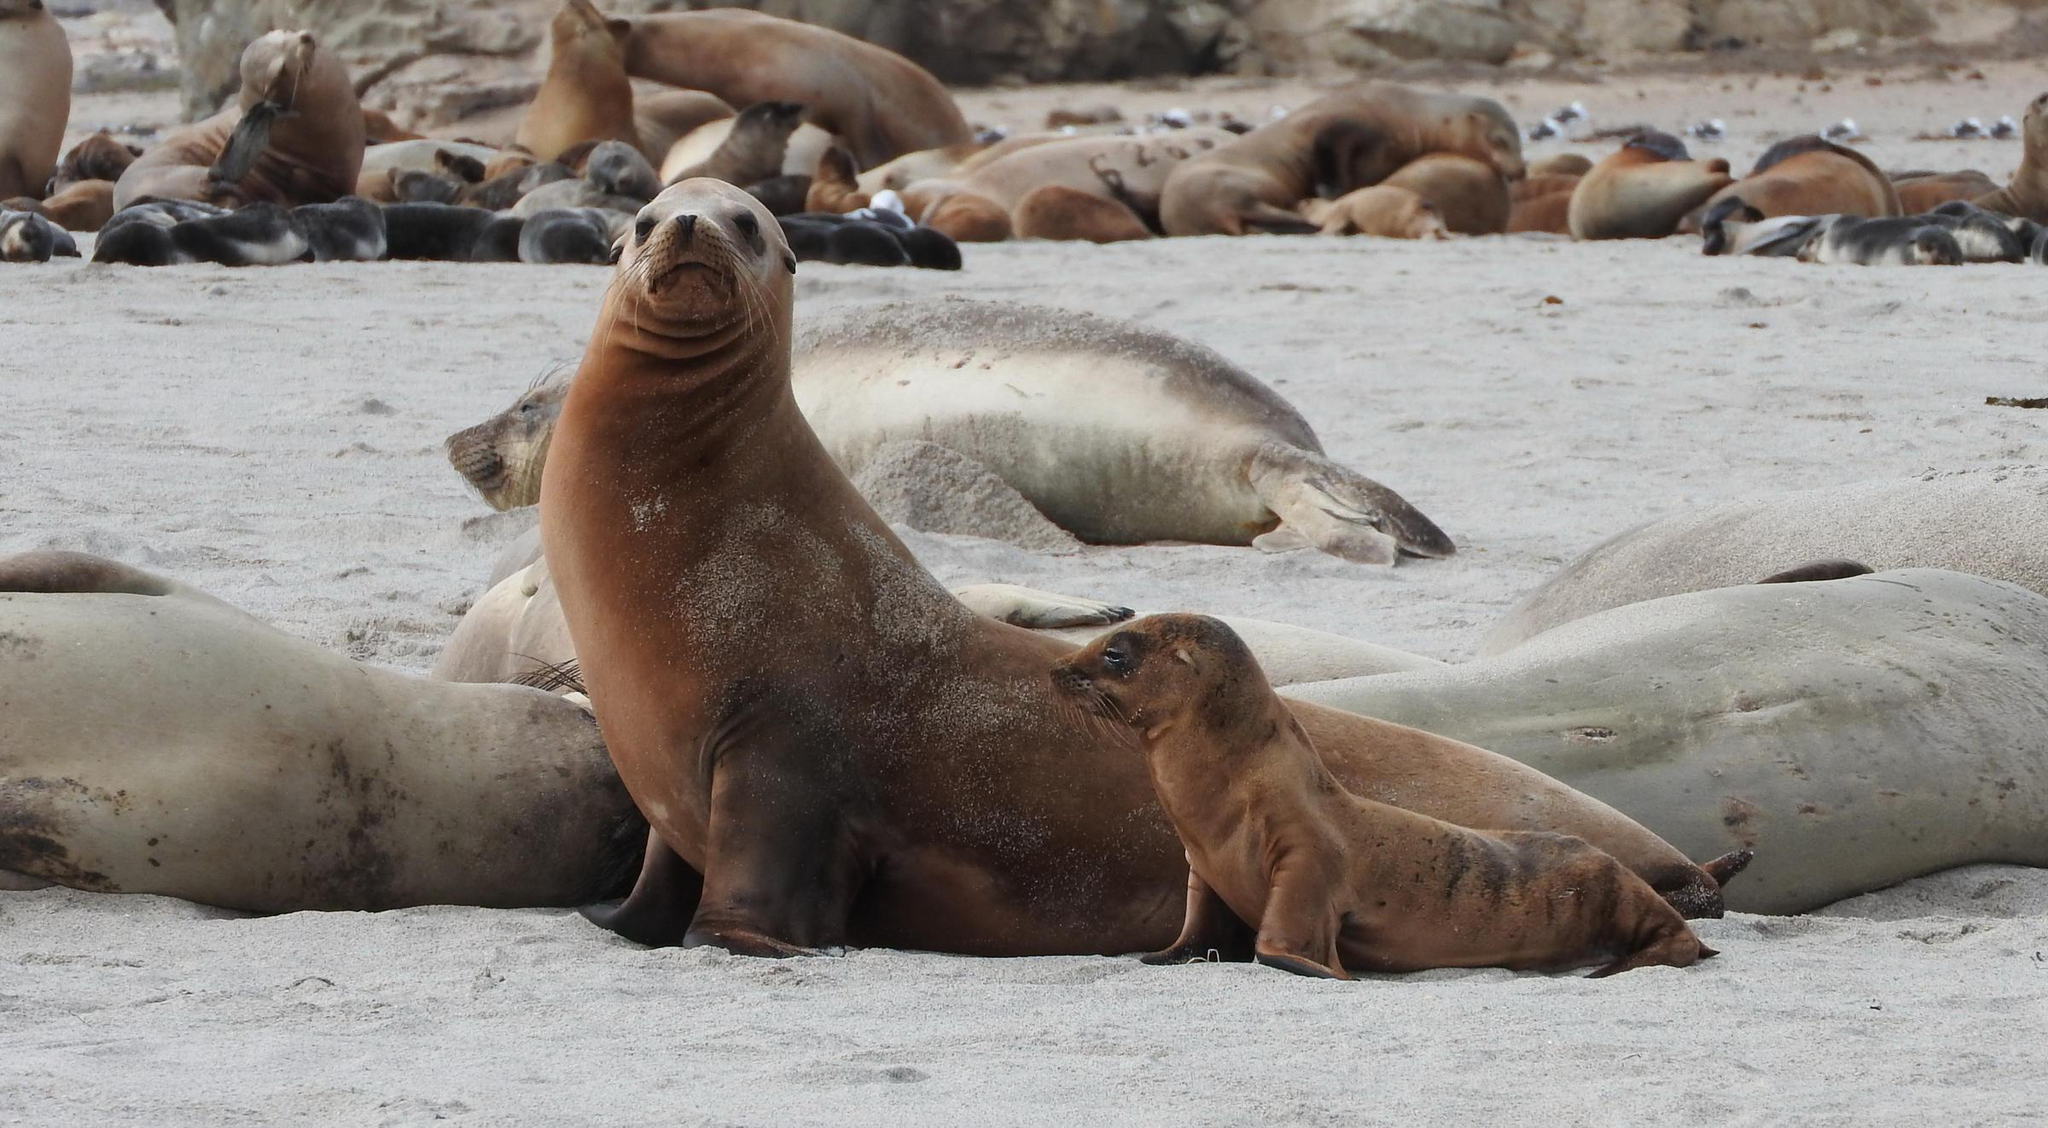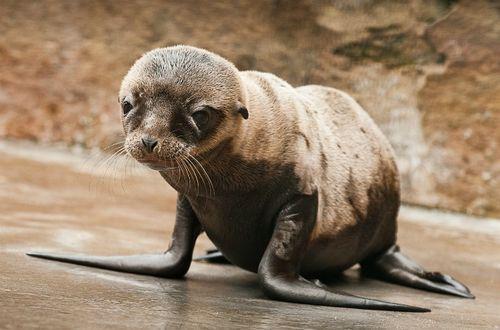The first image is the image on the left, the second image is the image on the right. Given the left and right images, does the statement "The left image contains exactly two seals." hold true? Answer yes or no. No. The first image is the image on the left, the second image is the image on the right. For the images displayed, is the sentence "There are 5 sea lions in total." factually correct? Answer yes or no. No. 